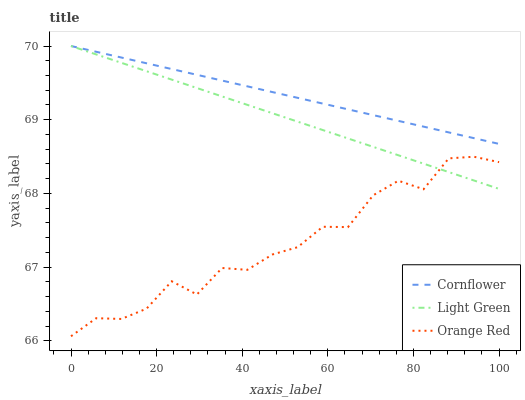Does Light Green have the minimum area under the curve?
Answer yes or no. No. Does Light Green have the maximum area under the curve?
Answer yes or no. No. Is Light Green the smoothest?
Answer yes or no. No. Is Light Green the roughest?
Answer yes or no. No. Does Light Green have the lowest value?
Answer yes or no. No. Does Orange Red have the highest value?
Answer yes or no. No. Is Orange Red less than Cornflower?
Answer yes or no. Yes. Is Cornflower greater than Orange Red?
Answer yes or no. Yes. Does Orange Red intersect Cornflower?
Answer yes or no. No. 